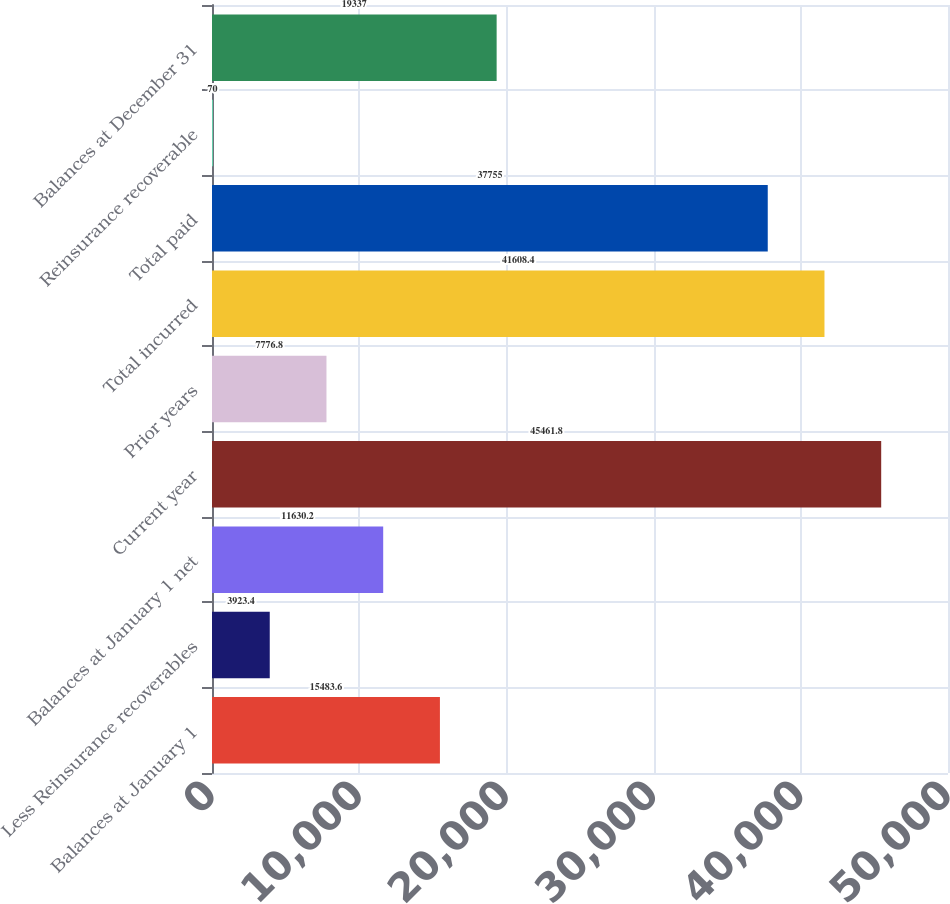<chart> <loc_0><loc_0><loc_500><loc_500><bar_chart><fcel>Balances at January 1<fcel>Less Reinsurance recoverables<fcel>Balances at January 1 net<fcel>Current year<fcel>Prior years<fcel>Total incurred<fcel>Total paid<fcel>Reinsurance recoverable<fcel>Balances at December 31<nl><fcel>15483.6<fcel>3923.4<fcel>11630.2<fcel>45461.8<fcel>7776.8<fcel>41608.4<fcel>37755<fcel>70<fcel>19337<nl></chart> 